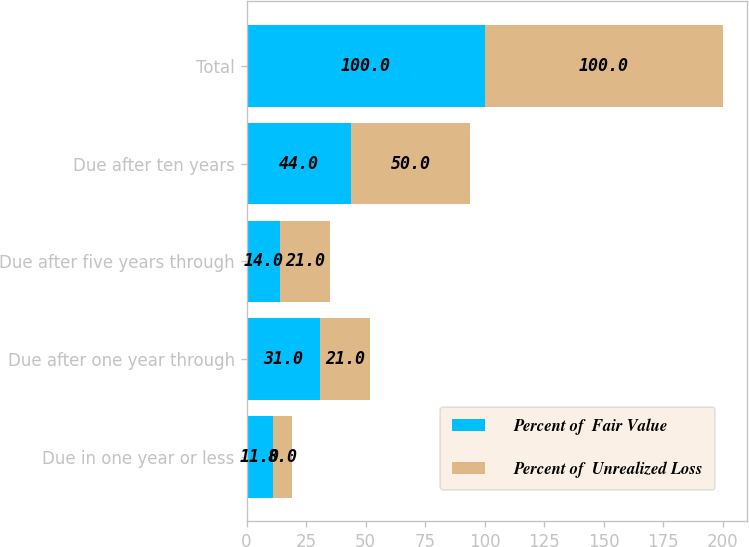<chart> <loc_0><loc_0><loc_500><loc_500><stacked_bar_chart><ecel><fcel>Due in one year or less<fcel>Due after one year through<fcel>Due after five years through<fcel>Due after ten years<fcel>Total<nl><fcel>Percent of  Fair Value<fcel>11<fcel>31<fcel>14<fcel>44<fcel>100<nl><fcel>Percent of  Unrealized Loss<fcel>8<fcel>21<fcel>21<fcel>50<fcel>100<nl></chart> 